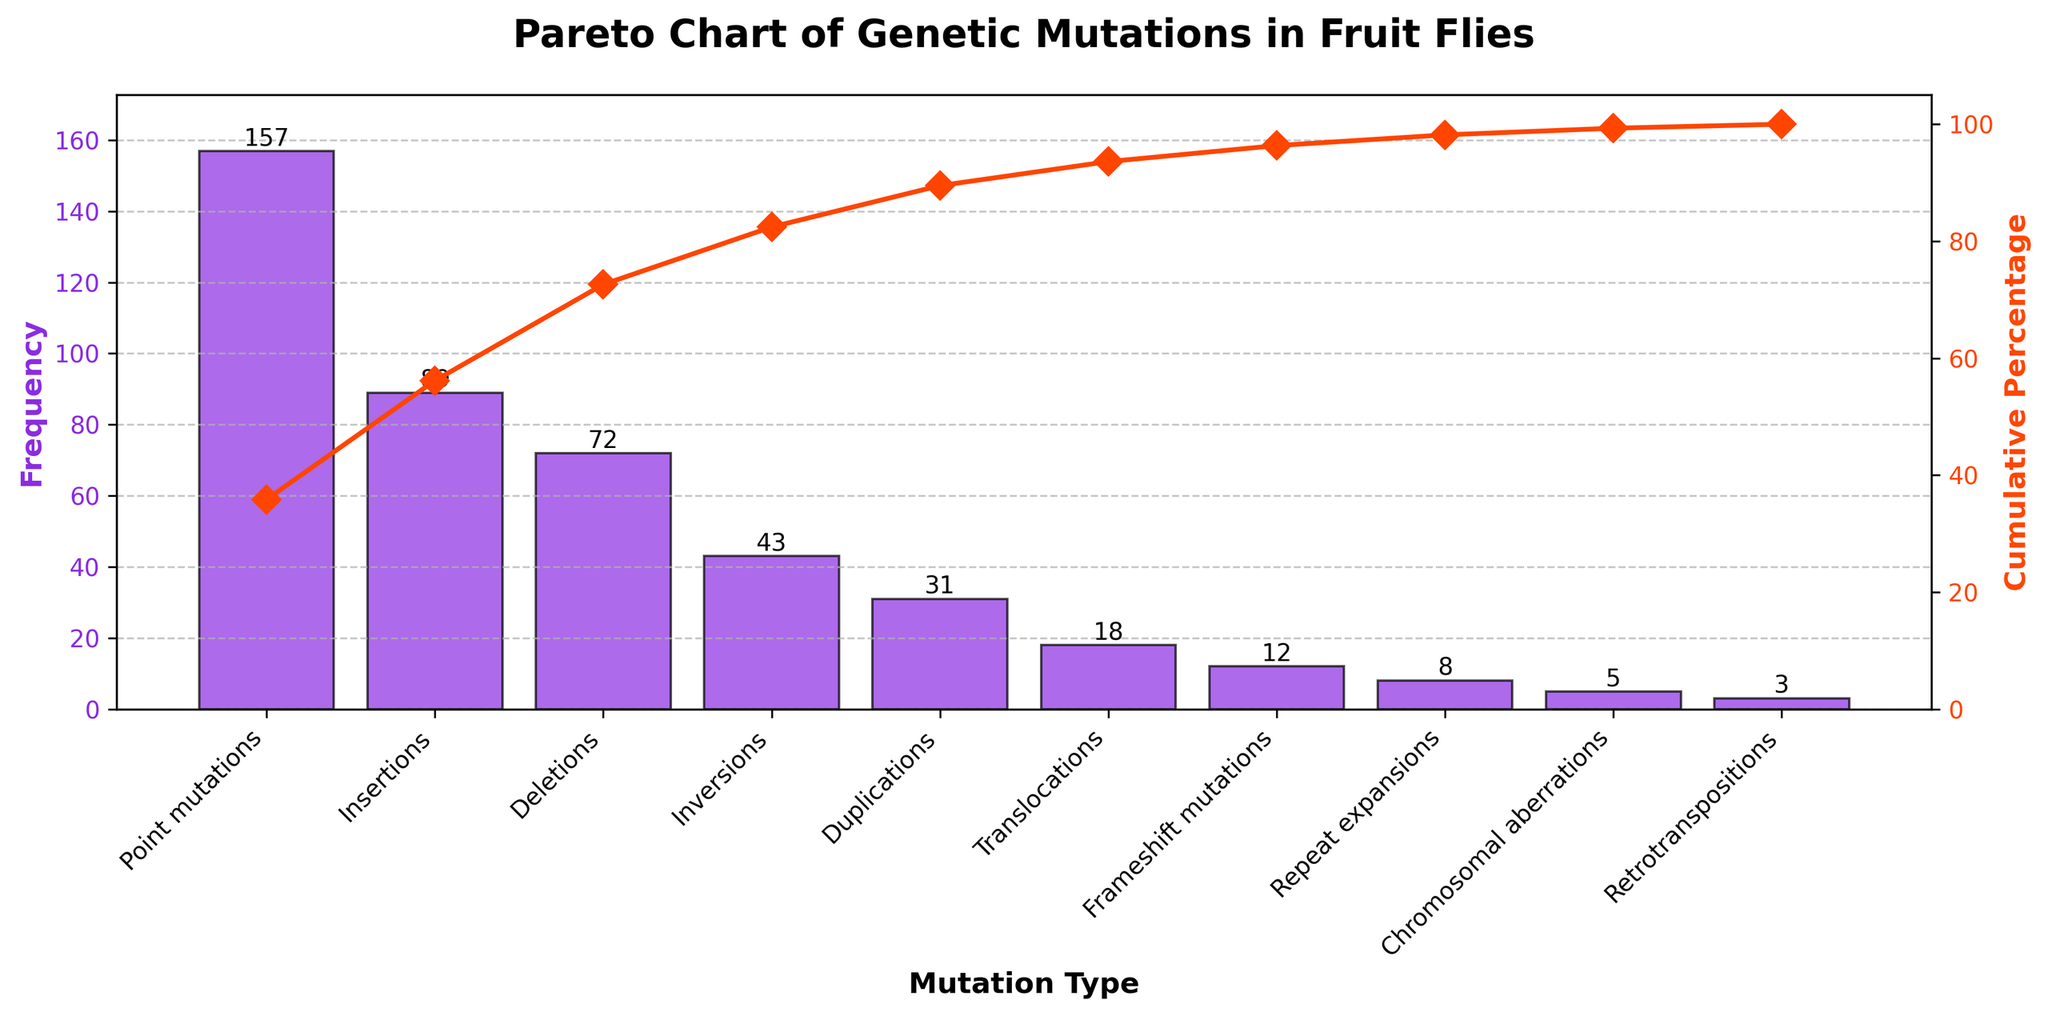What type of mutation has the highest frequency in the population of fruit flies? Identify the tallest bar in the figure, which represents the mutation type with the highest frequency.
Answer: Point mutations What is the cumulative percentage for Deletions in the population of fruit flies? Find the bar for Deletions, then follow the corresponding line on the secondary y-axis to read the cumulative percentage value.
Answer: Around 73% How does the frequency of Insertions compare to Deletions? Look at the heights of the bars for Insertions and Deletions and compare their values. Insertions have a taller bar than Deletions, indicating a higher frequency.
Answer: Insertions are more frequent than Deletions What is the total frequency of all mutation types combined? Add up the frequency values of all the bars: 157 + 89 + 72 + 43 + 31 + 18 + 12 + 8 + 5 + 3 = 438
Answer: 438 Which mutation type contributes the smallest frequency to the population? Identify the shortest bar in the figure, representing the mutation type with the smallest frequency.
Answer: Retrotranspositions How many mutation types have a frequency greater than 50? Count the number of bars that exceed the frequency value of 50 on the y-axis.
Answer: 3 What percentage of the total frequency is contributed by the top three mutation types combined? Add the frequencies of the top three mutation types (Point mutations, Insertions, Deletions) and divide by the total frequency, then multiply by 100: (157 + 89 + 72) / 438 * 100 ≈ 73%
Answer: Around 73% What is the cumulative percentage just before the Frameshift mutations? Locate the cumulative percentage point after the mutation type just before Frameshift mutations on the secondary y-axis (which is Duplications).
Answer: Around 92% Which mutation type has nearly the same frequency as Duplications? Compare the frequencies visually or read the values. Deletions have a frequency close to Duplications.
Answer: Deletions At what cumulative percentage does the graph hit the 100% mark? Read the point where the cumulative percentage line reaches 100% on the secondary y-axis.
Answer: Chromosomal aberrations 